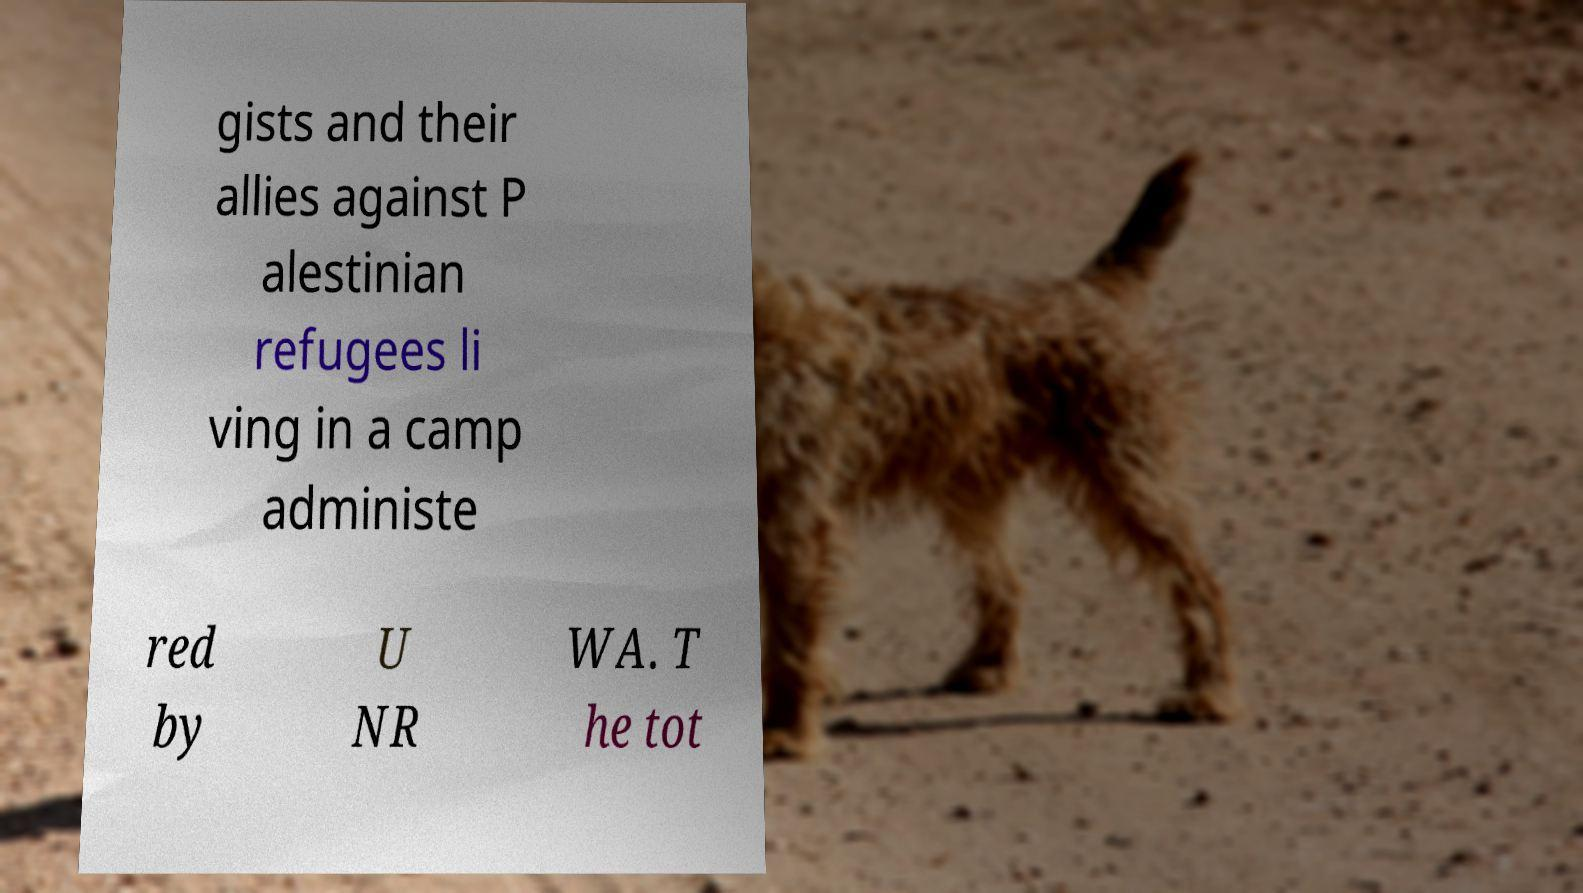There's text embedded in this image that I need extracted. Can you transcribe it verbatim? gists and their allies against P alestinian refugees li ving in a camp administe red by U NR WA. T he tot 